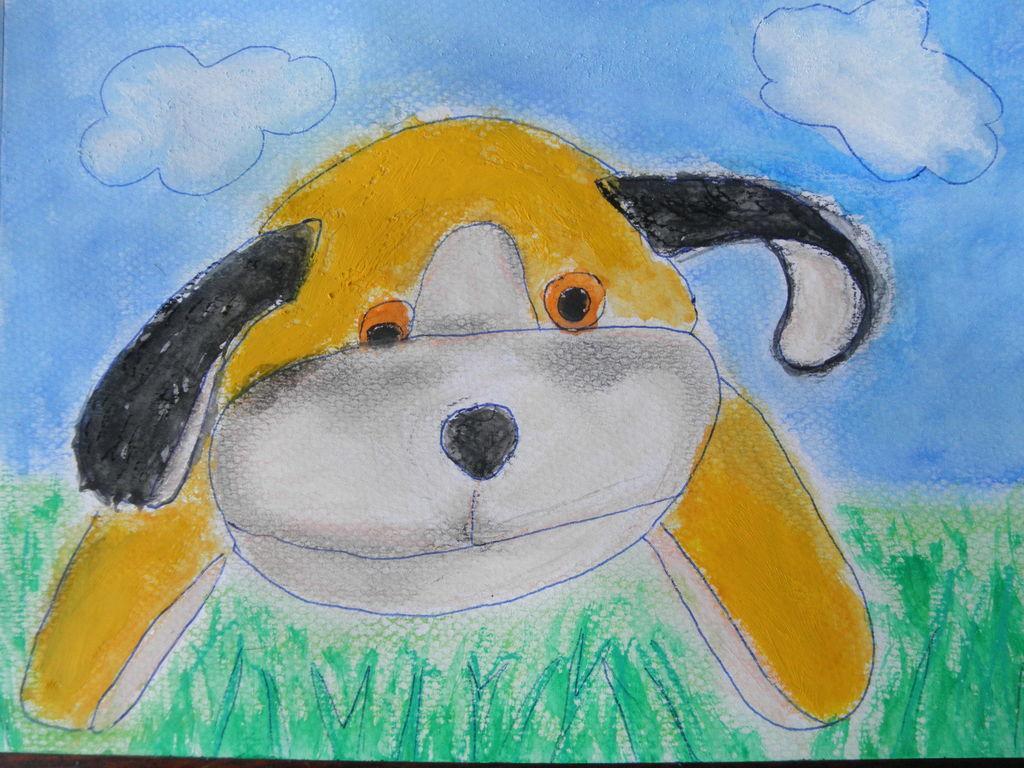In one or two sentences, can you explain what this image depicts? In this image I can see a toy dog in yellow, black and white color. I can see the grass. I can see few clouds and the sky is in blue color. 